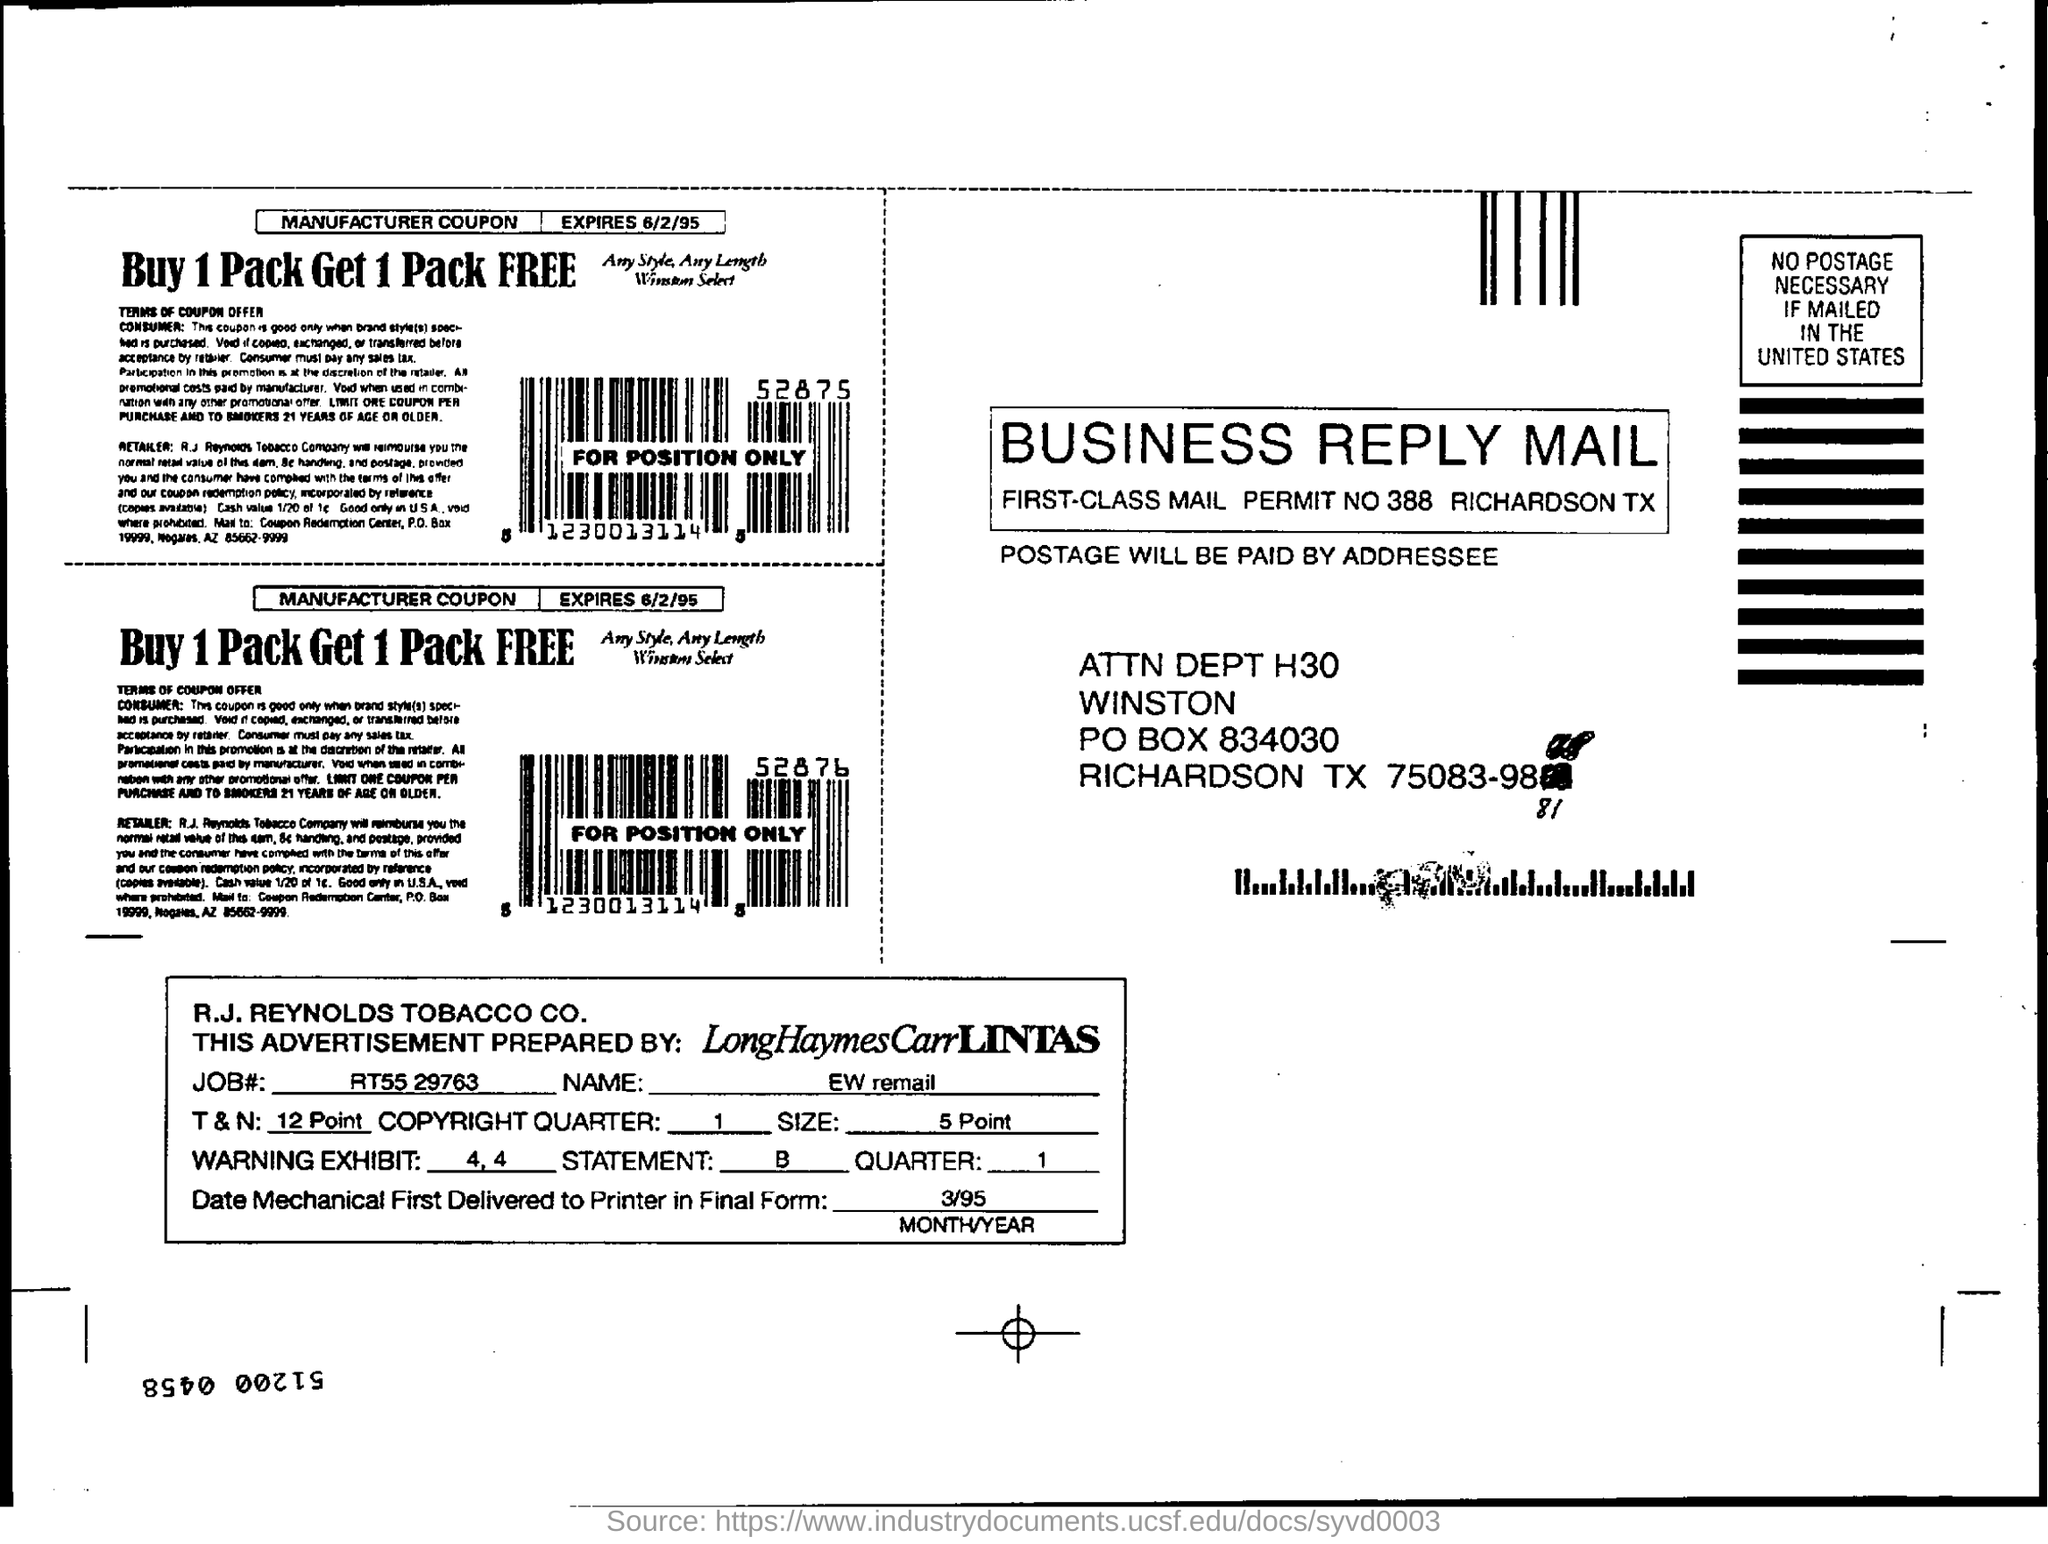Mention a couple of crucial points in this snapshot. The postage will be paid by the addressee. The mechanical final form was delivered to the printer on 3/95. The permit number of the mail is 388. The job number mentioned in the advertisement is RT55 29763. Please provide the job number, RT55 29763. 